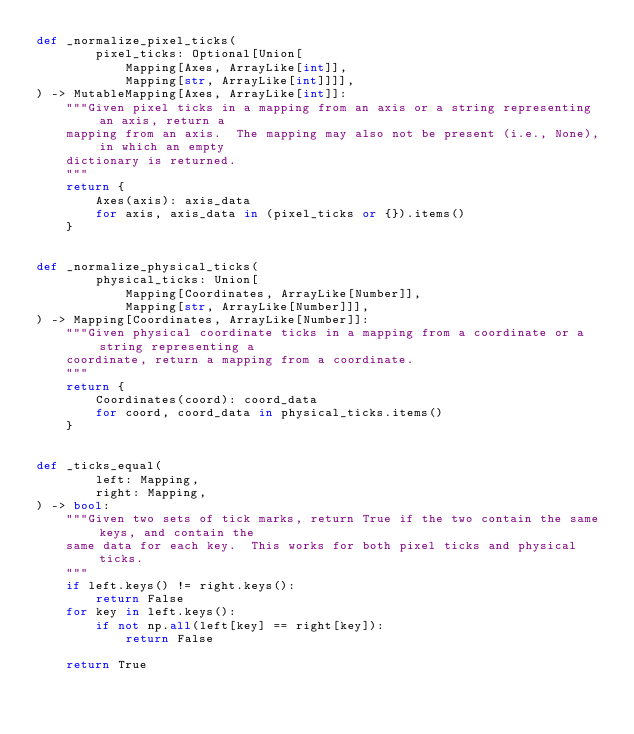Convert code to text. <code><loc_0><loc_0><loc_500><loc_500><_Python_>def _normalize_pixel_ticks(
        pixel_ticks: Optional[Union[
            Mapping[Axes, ArrayLike[int]],
            Mapping[str, ArrayLike[int]]]],
) -> MutableMapping[Axes, ArrayLike[int]]:
    """Given pixel ticks in a mapping from an axis or a string representing an axis, return a
    mapping from an axis.  The mapping may also not be present (i.e., None), in which an empty
    dictionary is returned.
    """
    return {
        Axes(axis): axis_data
        for axis, axis_data in (pixel_ticks or {}).items()
    }


def _normalize_physical_ticks(
        physical_ticks: Union[
            Mapping[Coordinates, ArrayLike[Number]],
            Mapping[str, ArrayLike[Number]]],
) -> Mapping[Coordinates, ArrayLike[Number]]:
    """Given physical coordinate ticks in a mapping from a coordinate or a string representing a
    coordinate, return a mapping from a coordinate.
    """
    return {
        Coordinates(coord): coord_data
        for coord, coord_data in physical_ticks.items()
    }


def _ticks_equal(
        left: Mapping,
        right: Mapping,
) -> bool:
    """Given two sets of tick marks, return True if the two contain the same keys, and contain the
    same data for each key.  This works for both pixel ticks and physical ticks.
    """
    if left.keys() != right.keys():
        return False
    for key in left.keys():
        if not np.all(left[key] == right[key]):
            return False

    return True
</code> 